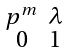Convert formula to latex. <formula><loc_0><loc_0><loc_500><loc_500>\begin{smallmatrix} p ^ { m } & \lambda \\ 0 & 1 \end{smallmatrix}</formula> 